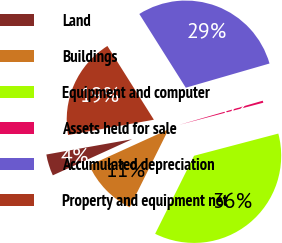Convert chart to OTSL. <chart><loc_0><loc_0><loc_500><loc_500><pie_chart><fcel>Land<fcel>Buildings<fcel>Equipment and computer<fcel>Assets held for sale<fcel>Accumulated depreciation<fcel>Property and equipment net<nl><fcel>3.99%<fcel>10.84%<fcel>36.46%<fcel>0.38%<fcel>29.47%<fcel>18.86%<nl></chart> 